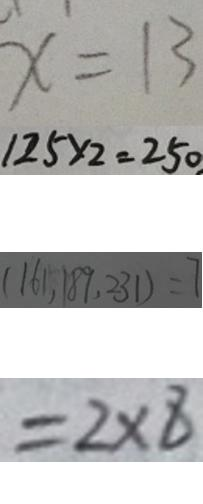Convert formula to latex. <formula><loc_0><loc_0><loc_500><loc_500>x = 1 3 
 1 2 5 \times 2 = 2 5 0 
 ( 1 6 1 , 1 8 9 , 2 3 1 ) = 7 
 = 2 \times 8</formula> 